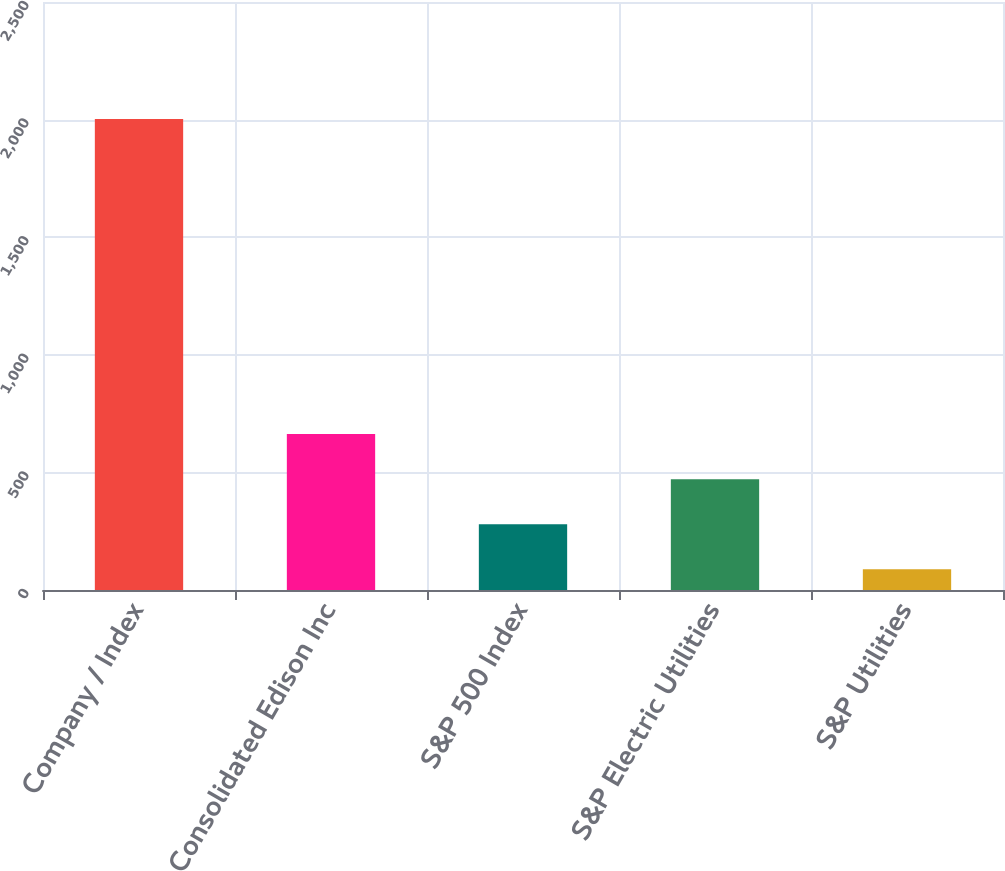Convert chart to OTSL. <chart><loc_0><loc_0><loc_500><loc_500><bar_chart><fcel>Company / Index<fcel>Consolidated Edison Inc<fcel>S&P 500 Index<fcel>S&P Electric Utilities<fcel>S&P Utilities<nl><fcel>2003<fcel>662.77<fcel>279.85<fcel>471.31<fcel>88.39<nl></chart> 